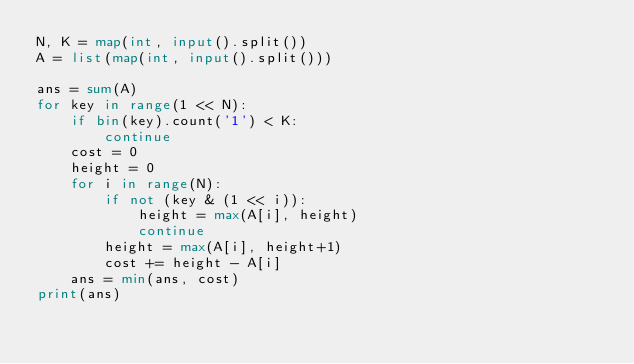<code> <loc_0><loc_0><loc_500><loc_500><_Python_>N, K = map(int, input().split())
A = list(map(int, input().split()))

ans = sum(A)
for key in range(1 << N):
    if bin(key).count('1') < K:
        continue
    cost = 0
    height = 0
    for i in range(N):
        if not (key & (1 << i)):
            height = max(A[i], height)
            continue
        height = max(A[i], height+1)
        cost += height - A[i]
    ans = min(ans, cost)
print(ans)




</code> 